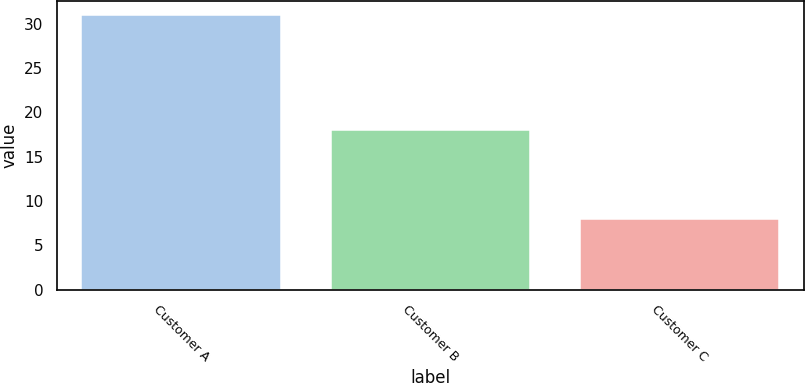Convert chart. <chart><loc_0><loc_0><loc_500><loc_500><bar_chart><fcel>Customer A<fcel>Customer B<fcel>Customer C<nl><fcel>31<fcel>18<fcel>8<nl></chart> 